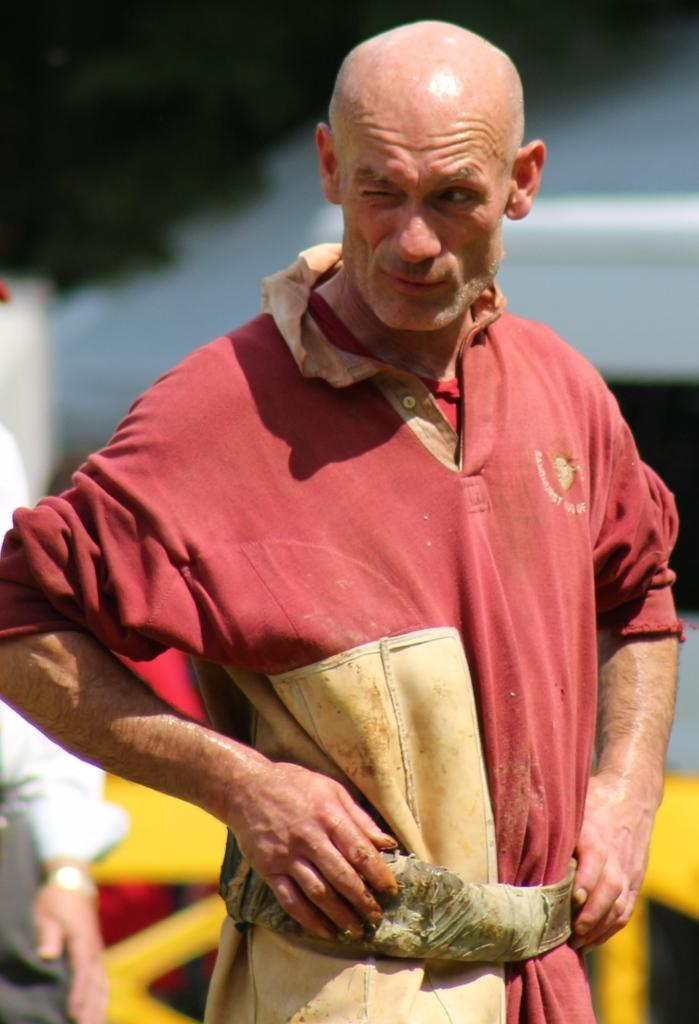What is the main subject of the image? There is a man standing in the image. What is the man wearing? The man is wearing a red dress. Can you describe the positioning of the second man in the image? There is another man behind the first man. What type of spy equipment can be seen in the man's hands in the image? There is no spy equipment visible in the man's hands in the image. What kind of steel structure is present in the background of the image? There is no steel structure present in the image. 